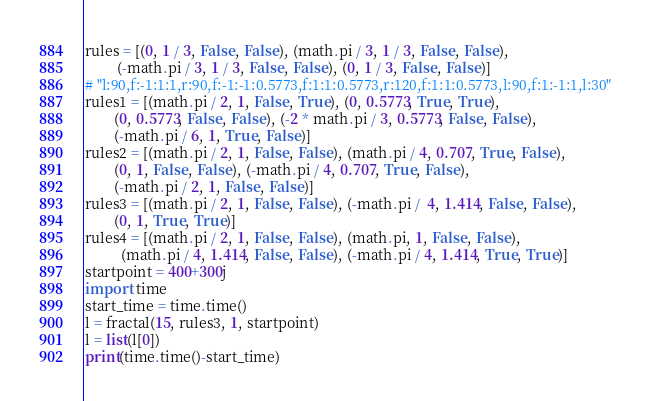<code> <loc_0><loc_0><loc_500><loc_500><_Python_>rules = [(0, 1 / 3, False, False), (math.pi / 3, 1 / 3, False, False),
         (-math.pi / 3, 1 / 3, False, False), (0, 1 / 3, False, False)]
# "l:90,f:-1:1:1,r:90,f:-1:-1:0.5773,f:1:1:0.5773,r:120,f:1:1:0.5773,l:90,f:1:-1:1,l:30"
rules1 = [(math.pi / 2, 1, False, True), (0, 0.5773, True, True), 
        (0, 0.5773, False, False), (-2 * math.pi / 3, 0.5773, False, False), 
        (-math.pi / 6, 1, True, False)]
rules2 = [(math.pi / 2, 1, False, False), (math.pi / 4, 0.707, True, False), 
        (0, 1, False, False), (-math.pi / 4, 0.707, True, False), 
        (-math.pi / 2, 1, False, False)]
rules3 = [(math.pi / 2, 1, False, False), (-math.pi /  4, 1.414, False, False),
        (0, 1, True, True)]
rules4 = [(math.pi / 2, 1, False, False), (math.pi, 1, False, False),
          (math.pi / 4, 1.414, False, False), (-math.pi / 4, 1.414, True, True)]
startpoint = 400+300j
import time
start_time = time.time()
l = fractal(15, rules3, 1, startpoint)
l = list(l[0])
print(time.time()-start_time)
</code> 